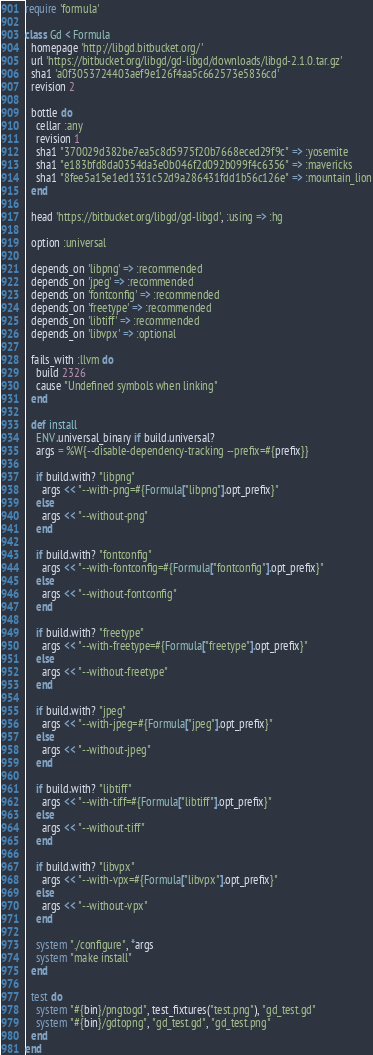<code> <loc_0><loc_0><loc_500><loc_500><_Ruby_>require 'formula'

class Gd < Formula
  homepage 'http://libgd.bitbucket.org/'
  url 'https://bitbucket.org/libgd/gd-libgd/downloads/libgd-2.1.0.tar.gz'
  sha1 'a0f3053724403aef9e126f4aa5c662573e5836cd'
  revision 2

  bottle do
    cellar :any
    revision 1
    sha1 "370029d382be7ea5c8d5975f20b7668eced29f9c" => :yosemite
    sha1 "e183bfd8da0354da3e0b046f2d092b099f4c6356" => :mavericks
    sha1 "8fee5a15e1ed1331c52d9a286431fdd1b56c126e" => :mountain_lion
  end

  head 'https://bitbucket.org/libgd/gd-libgd', :using => :hg

  option :universal

  depends_on 'libpng' => :recommended
  depends_on 'jpeg' => :recommended
  depends_on 'fontconfig' => :recommended
  depends_on 'freetype' => :recommended
  depends_on 'libtiff' => :recommended
  depends_on 'libvpx' => :optional

  fails_with :llvm do
    build 2326
    cause "Undefined symbols when linking"
  end

  def install
    ENV.universal_binary if build.universal?
    args = %W{--disable-dependency-tracking --prefix=#{prefix}}

    if build.with? "libpng"
      args << "--with-png=#{Formula["libpng"].opt_prefix}"
    else
      args << "--without-png"
    end

    if build.with? "fontconfig"
      args << "--with-fontconfig=#{Formula["fontconfig"].opt_prefix}"
    else
      args << "--without-fontconfig"
    end

    if build.with? "freetype"
      args << "--with-freetype=#{Formula["freetype"].opt_prefix}"
    else
      args << "--without-freetype"
    end

    if build.with? "jpeg"
      args << "--with-jpeg=#{Formula["jpeg"].opt_prefix}"
    else
      args << "--without-jpeg"
    end

    if build.with? "libtiff"
      args << "--with-tiff=#{Formula["libtiff"].opt_prefix}"
    else
      args << "--without-tiff"
    end

    if build.with? "libvpx"
      args << "--with-vpx=#{Formula["libvpx"].opt_prefix}"
    else
      args << "--without-vpx"
    end

    system "./configure", *args
    system "make install"
  end

  test do
    system "#{bin}/pngtogd", test_fixtures("test.png"), "gd_test.gd"
    system "#{bin}/gdtopng", "gd_test.gd", "gd_test.png"
  end
end
</code> 